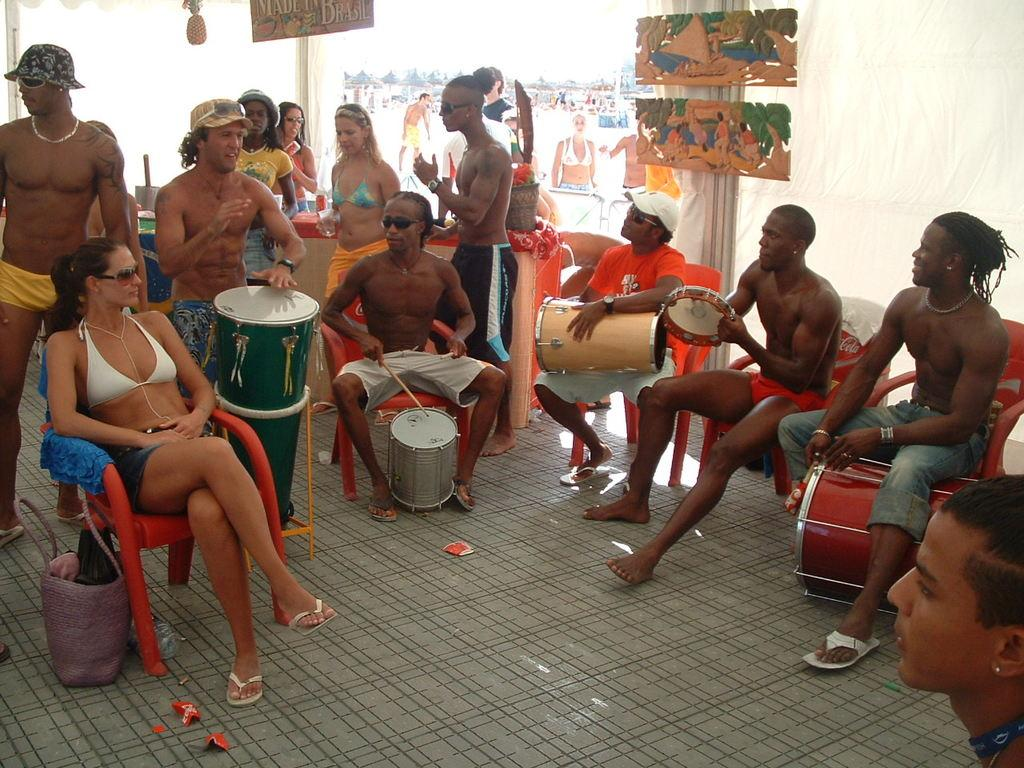What are the people in the image doing? The persons in the image are beating drums. How are the persons positioned while performing this activity? The persons are sitting on chairs. What can be seen on the wall in the background of the image? There are paintings on the wall in the background of the image. What type of milk is being served with the fork in the image? There is no milk or fork present in the image; the persons are beating drums while sitting on chairs. 